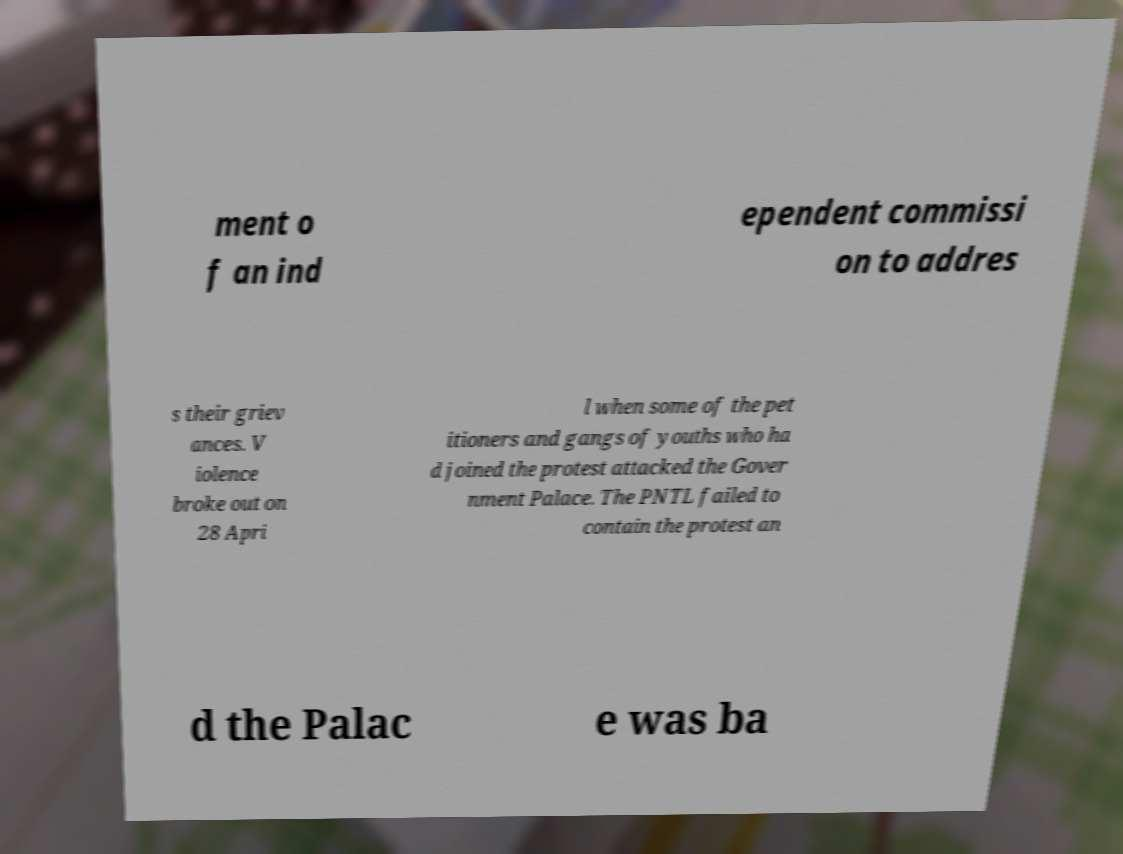Could you extract and type out the text from this image? ment o f an ind ependent commissi on to addres s their griev ances. V iolence broke out on 28 Apri l when some of the pet itioners and gangs of youths who ha d joined the protest attacked the Gover nment Palace. The PNTL failed to contain the protest an d the Palac e was ba 